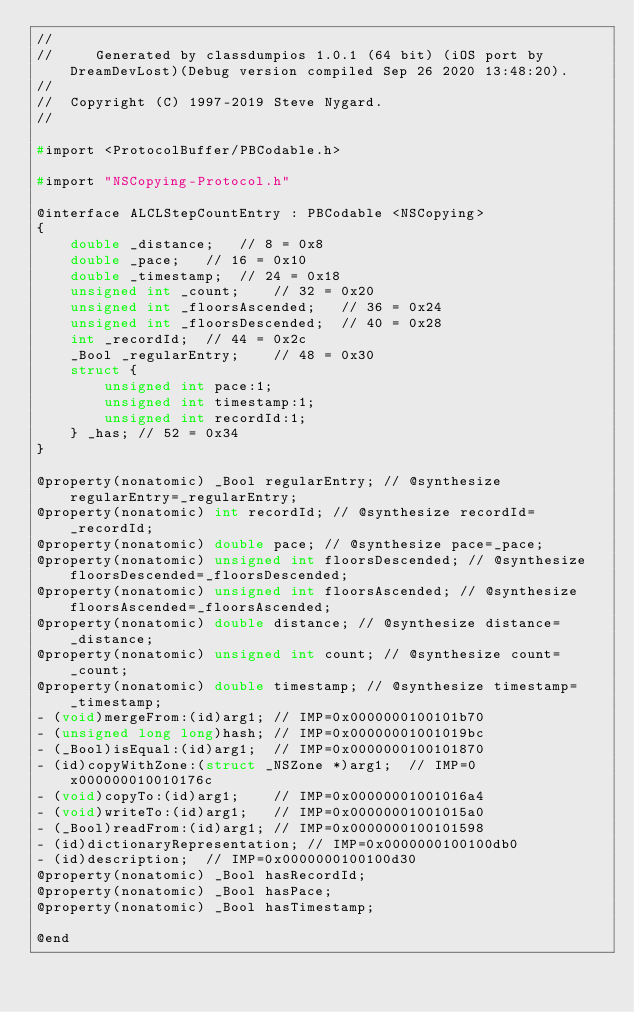<code> <loc_0><loc_0><loc_500><loc_500><_C_>//
//     Generated by classdumpios 1.0.1 (64 bit) (iOS port by DreamDevLost)(Debug version compiled Sep 26 2020 13:48:20).
//
//  Copyright (C) 1997-2019 Steve Nygard.
//

#import <ProtocolBuffer/PBCodable.h>

#import "NSCopying-Protocol.h"

@interface ALCLStepCountEntry : PBCodable <NSCopying>
{
    double _distance;	// 8 = 0x8
    double _pace;	// 16 = 0x10
    double _timestamp;	// 24 = 0x18
    unsigned int _count;	// 32 = 0x20
    unsigned int _floorsAscended;	// 36 = 0x24
    unsigned int _floorsDescended;	// 40 = 0x28
    int _recordId;	// 44 = 0x2c
    _Bool _regularEntry;	// 48 = 0x30
    struct {
        unsigned int pace:1;
        unsigned int timestamp:1;
        unsigned int recordId:1;
    } _has;	// 52 = 0x34
}

@property(nonatomic) _Bool regularEntry; // @synthesize regularEntry=_regularEntry;
@property(nonatomic) int recordId; // @synthesize recordId=_recordId;
@property(nonatomic) double pace; // @synthesize pace=_pace;
@property(nonatomic) unsigned int floorsDescended; // @synthesize floorsDescended=_floorsDescended;
@property(nonatomic) unsigned int floorsAscended; // @synthesize floorsAscended=_floorsAscended;
@property(nonatomic) double distance; // @synthesize distance=_distance;
@property(nonatomic) unsigned int count; // @synthesize count=_count;
@property(nonatomic) double timestamp; // @synthesize timestamp=_timestamp;
- (void)mergeFrom:(id)arg1;	// IMP=0x0000000100101b70
- (unsigned long long)hash;	// IMP=0x00000001001019bc
- (_Bool)isEqual:(id)arg1;	// IMP=0x0000000100101870
- (id)copyWithZone:(struct _NSZone *)arg1;	// IMP=0x000000010010176c
- (void)copyTo:(id)arg1;	// IMP=0x00000001001016a4
- (void)writeTo:(id)arg1;	// IMP=0x00000001001015a0
- (_Bool)readFrom:(id)arg1;	// IMP=0x0000000100101598
- (id)dictionaryRepresentation;	// IMP=0x0000000100100db0
- (id)description;	// IMP=0x0000000100100d30
@property(nonatomic) _Bool hasRecordId;
@property(nonatomic) _Bool hasPace;
@property(nonatomic) _Bool hasTimestamp;

@end

</code> 